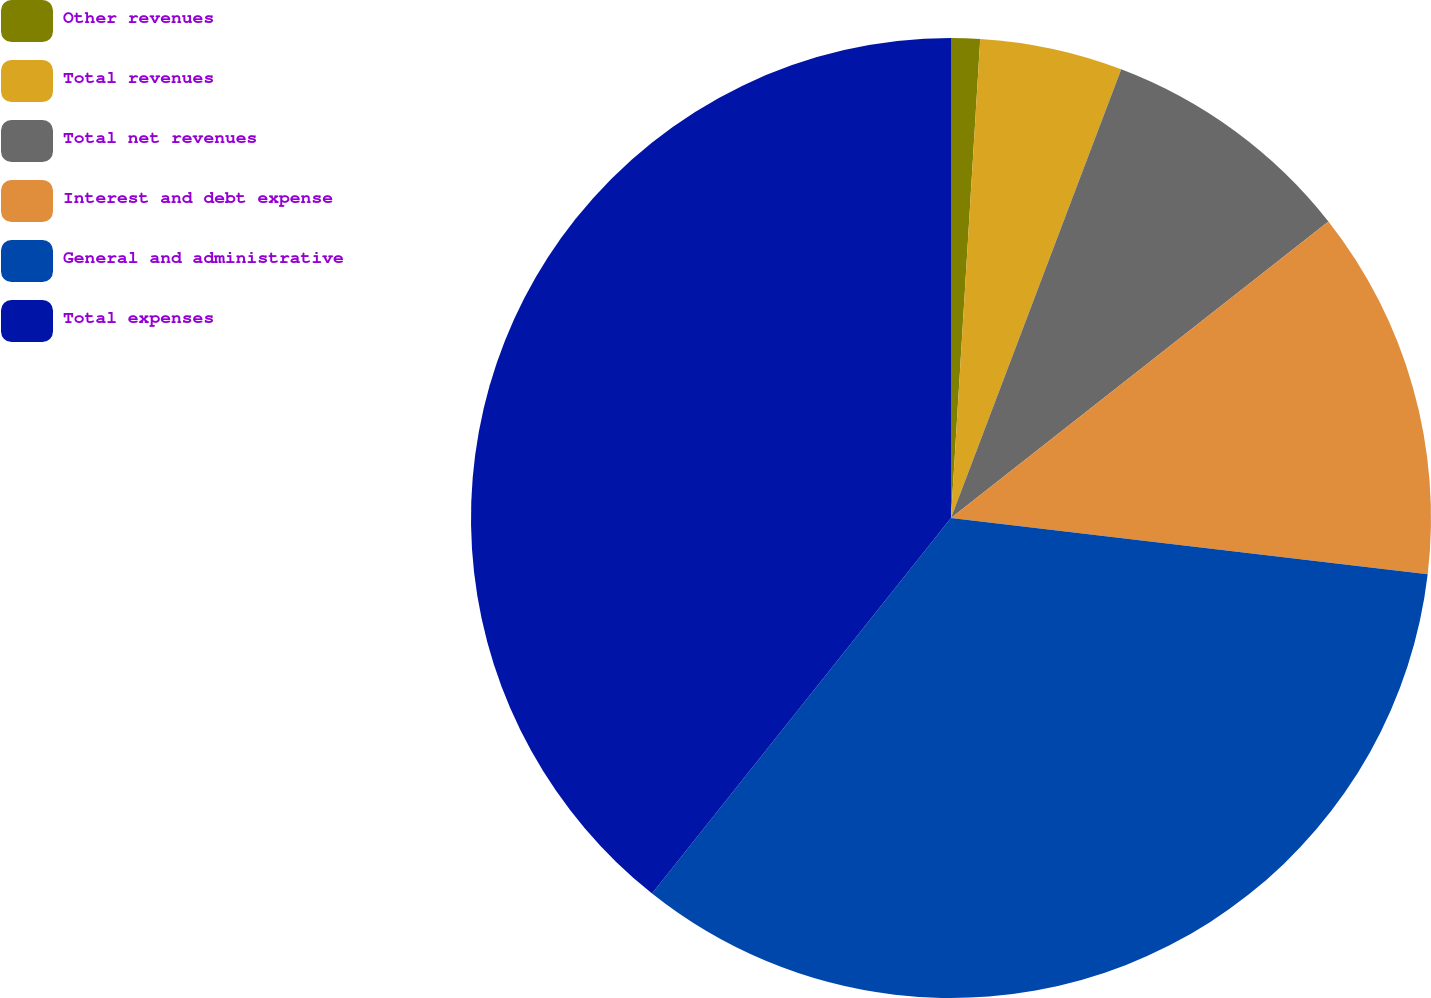<chart> <loc_0><loc_0><loc_500><loc_500><pie_chart><fcel>Other revenues<fcel>Total revenues<fcel>Total net revenues<fcel>Interest and debt expense<fcel>General and administrative<fcel>Total expenses<nl><fcel>0.97%<fcel>4.8%<fcel>8.63%<fcel>12.47%<fcel>33.83%<fcel>39.3%<nl></chart> 